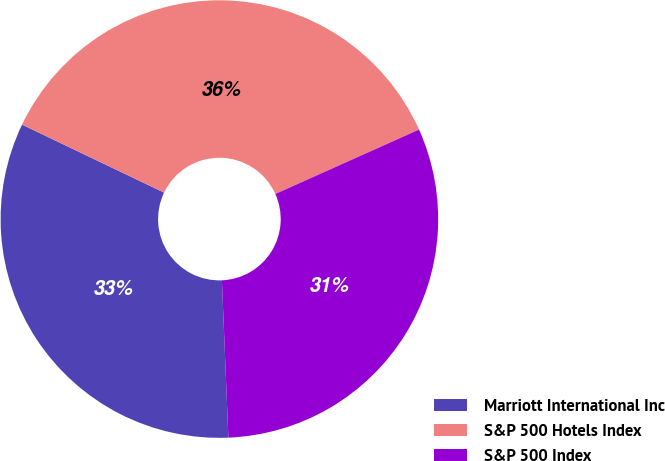Convert chart. <chart><loc_0><loc_0><loc_500><loc_500><pie_chart><fcel>Marriott International Inc<fcel>S&P 500 Hotels Index<fcel>S&P 500 Index<nl><fcel>32.76%<fcel>36.19%<fcel>31.05%<nl></chart> 